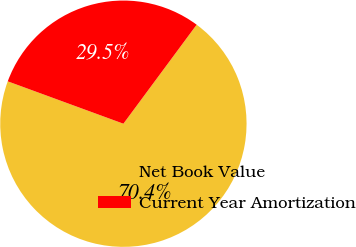Convert chart to OTSL. <chart><loc_0><loc_0><loc_500><loc_500><pie_chart><fcel>Net Book Value<fcel>Current Year Amortization<nl><fcel>70.45%<fcel>29.55%<nl></chart> 